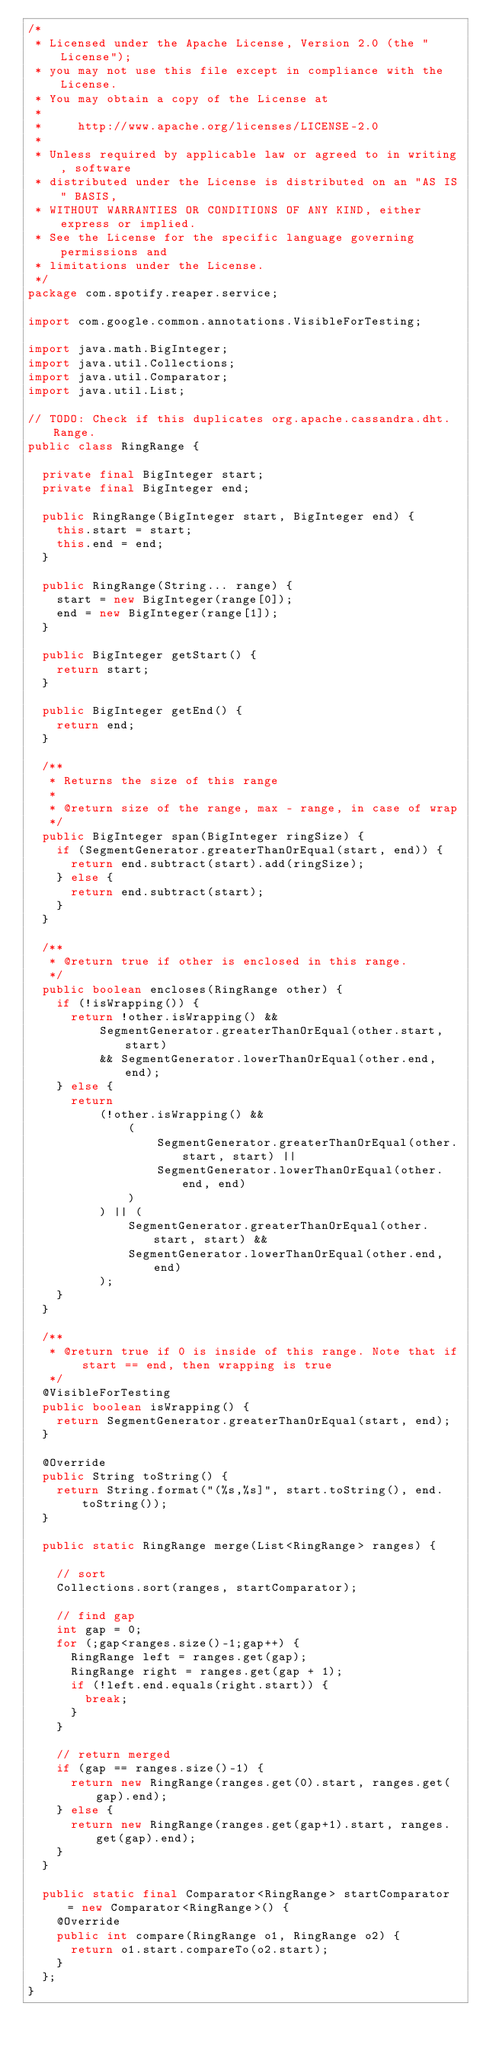<code> <loc_0><loc_0><loc_500><loc_500><_Java_>/*
 * Licensed under the Apache License, Version 2.0 (the "License");
 * you may not use this file except in compliance with the License.
 * You may obtain a copy of the License at
 *
 *     http://www.apache.org/licenses/LICENSE-2.0
 *
 * Unless required by applicable law or agreed to in writing, software
 * distributed under the License is distributed on an "AS IS" BASIS,
 * WITHOUT WARRANTIES OR CONDITIONS OF ANY KIND, either express or implied.
 * See the License for the specific language governing permissions and
 * limitations under the License.
 */
package com.spotify.reaper.service;

import com.google.common.annotations.VisibleForTesting;

import java.math.BigInteger;
import java.util.Collections;
import java.util.Comparator;
import java.util.List;

// TODO: Check if this duplicates org.apache.cassandra.dht.Range.
public class RingRange {

  private final BigInteger start;
  private final BigInteger end;

  public RingRange(BigInteger start, BigInteger end) {
    this.start = start;
    this.end = end;
  }

  public RingRange(String... range) {
    start = new BigInteger(range[0]);
    end = new BigInteger(range[1]);
  }

  public BigInteger getStart() {
    return start;
  }

  public BigInteger getEnd() {
    return end;
  }

  /**
   * Returns the size of this range
   *
   * @return size of the range, max - range, in case of wrap
   */
  public BigInteger span(BigInteger ringSize) {
    if (SegmentGenerator.greaterThanOrEqual(start, end)) {
      return end.subtract(start).add(ringSize);
    } else {
      return end.subtract(start);
    }
  }

  /**
   * @return true if other is enclosed in this range.
   */
  public boolean encloses(RingRange other) {
    if (!isWrapping()) {
      return !other.isWrapping() &&
          SegmentGenerator.greaterThanOrEqual(other.start, start)
          && SegmentGenerator.lowerThanOrEqual(other.end, end);
    } else {
      return
          (!other.isWrapping() &&
              (
                  SegmentGenerator.greaterThanOrEqual(other.start, start) ||
                  SegmentGenerator.lowerThanOrEqual(other.end, end)
              )
          ) || (
              SegmentGenerator.greaterThanOrEqual(other.start, start) &&
              SegmentGenerator.lowerThanOrEqual(other.end, end)
          );
    }
  }

  /**
   * @return true if 0 is inside of this range. Note that if start == end, then wrapping is true
   */
  @VisibleForTesting
  public boolean isWrapping() {
    return SegmentGenerator.greaterThanOrEqual(start, end);
  }

  @Override
  public String toString() {
    return String.format("(%s,%s]", start.toString(), end.toString());
  }

  public static RingRange merge(List<RingRange> ranges) {

    // sort
    Collections.sort(ranges, startComparator);

    // find gap
    int gap = 0;
    for (;gap<ranges.size()-1;gap++) {
      RingRange left = ranges.get(gap);
      RingRange right = ranges.get(gap + 1);
      if (!left.end.equals(right.start)) {
        break;
      }
    }

    // return merged
    if (gap == ranges.size()-1) {
      return new RingRange(ranges.get(0).start, ranges.get(gap).end);
    } else {
      return new RingRange(ranges.get(gap+1).start, ranges.get(gap).end);
    }
  }

  public static final Comparator<RingRange> startComparator = new Comparator<RingRange>() {
    @Override
    public int compare(RingRange o1, RingRange o2) {
      return o1.start.compareTo(o2.start);
    }
  };
}
</code> 